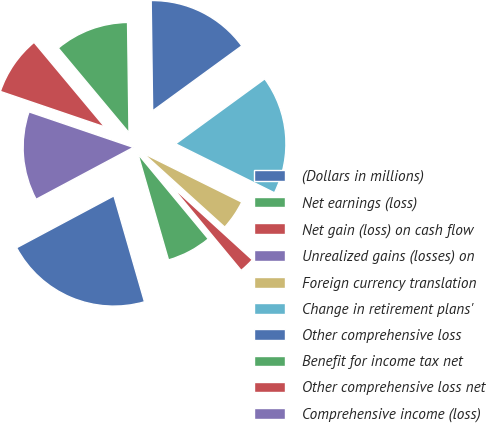Convert chart. <chart><loc_0><loc_0><loc_500><loc_500><pie_chart><fcel>(Dollars in millions)<fcel>Net earnings (loss)<fcel>Net gain (loss) on cash flow<fcel>Unrealized gains (losses) on<fcel>Foreign currency translation<fcel>Change in retirement plans'<fcel>Other comprehensive loss<fcel>Benefit for income tax net<fcel>Other comprehensive loss net<fcel>Comprehensive income (loss)<nl><fcel>21.66%<fcel>6.54%<fcel>2.22%<fcel>0.06%<fcel>4.38%<fcel>17.34%<fcel>15.18%<fcel>10.86%<fcel>8.7%<fcel>13.02%<nl></chart> 